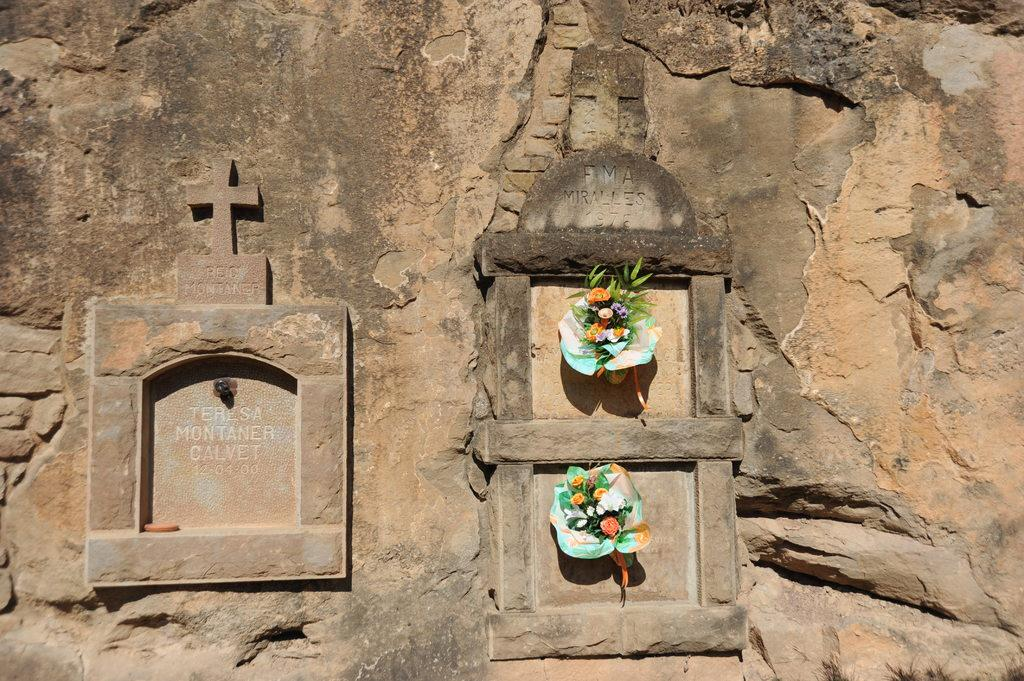What can be seen on the wall in the image? There are memorials carved on the wall in the image. What else is present in the image besides the carved memorials? There are flower bouquets in the image. What type of ear is visible on the wall in the image? There is no ear present on the wall in the image; it features carved memorials and flower bouquets. 